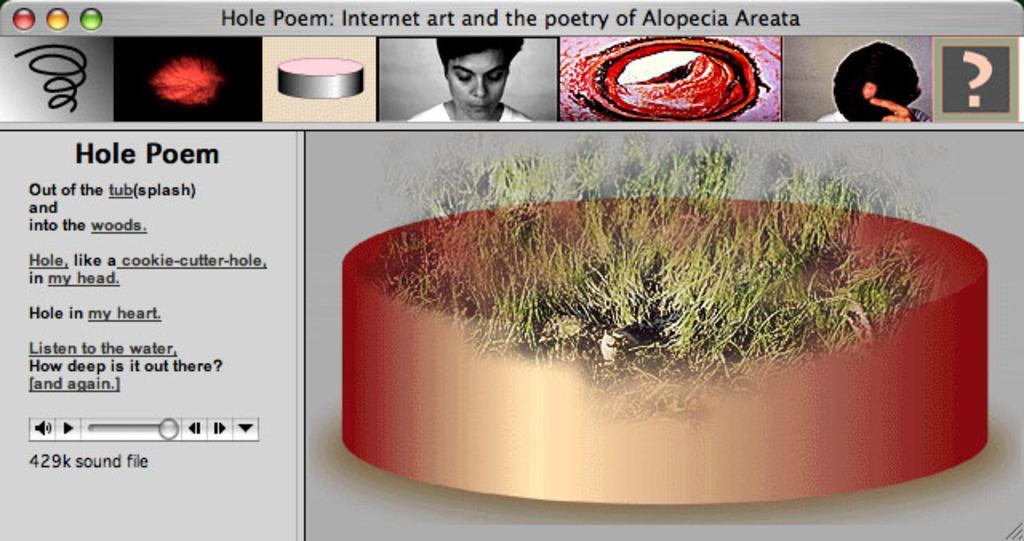In one or two sentences, can you explain what this image depicts? This is a screenshot of a screen, in this image there is text and pictures. 